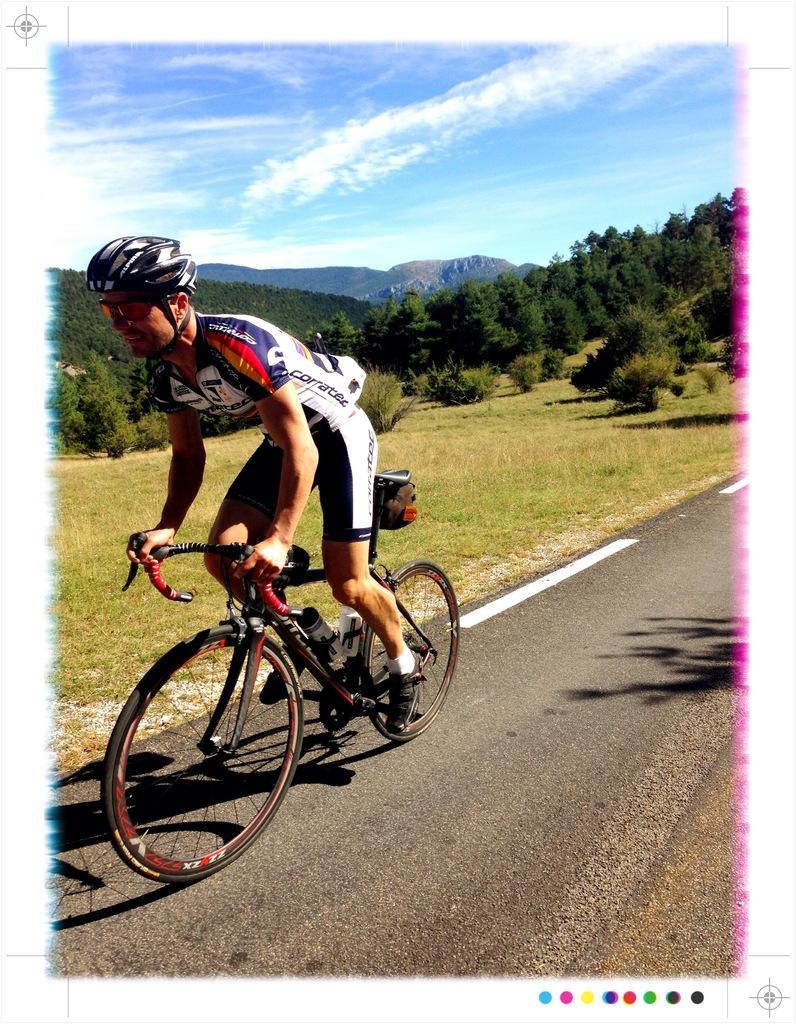Please provide a concise description of this image. In front of the image there is a person riding a bicycle on the road, beside him there is grass on the surface. In the background of the image there are trees and mountains. At the top of the image there are clouds in the sky. 